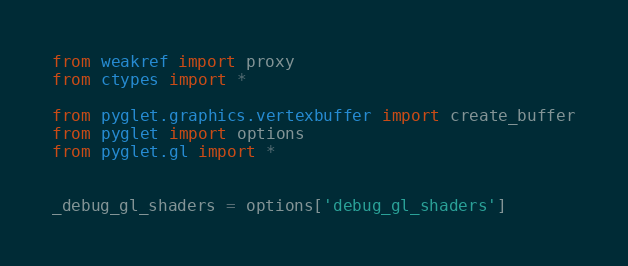Convert code to text. <code><loc_0><loc_0><loc_500><loc_500><_Python_>from weakref import proxy
from ctypes import *

from pyglet.graphics.vertexbuffer import create_buffer
from pyglet import options
from pyglet.gl import *


_debug_gl_shaders = options['debug_gl_shaders']

</code> 